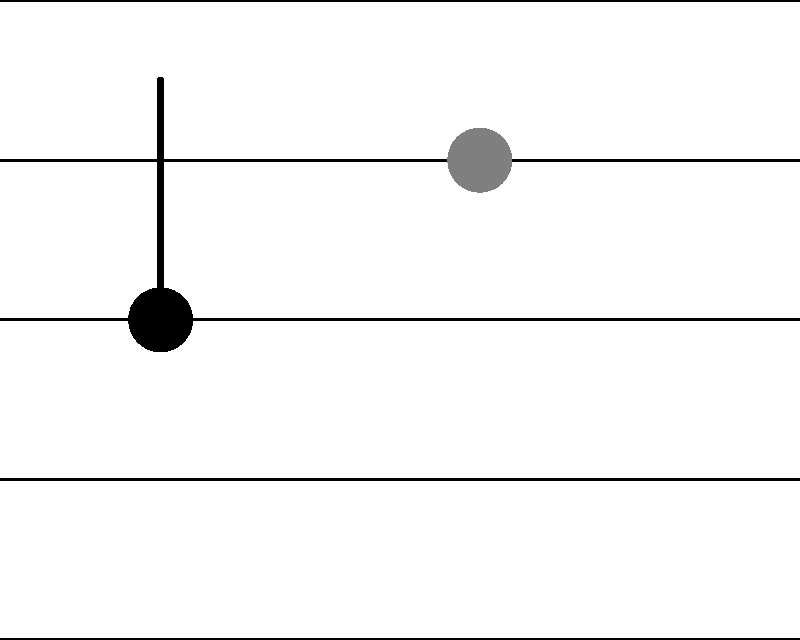In the musical staff above, note A is rotated 135° counterclockwise around point O to create note B. If the coordinates of point A are (1, 2) and the center of rotation O is at (2, 2), what are the coordinates of point B after the rotation? To find the coordinates of point B after rotation, we can use the rotation formula:

1) The general formula for rotating a point $(x, y)$ around the origin by an angle $\theta$ counterclockwise is:
   $x' = x \cos \theta - y \sin \theta$
   $y' = x \sin \theta + y \cos \theta$

2) However, we're rotating around (2, 2), not the origin. So first, we need to translate the point A to the origin:
   $(1, 2) \rightarrow (-1, 0)$

3) Now we apply the rotation formula with $\theta = 135°$:
   $\cos 135° = -\frac{\sqrt{2}}{2}$
   $\sin 135° = \frac{\sqrt{2}}{2}$

   $x' = -1 \cdot (-\frac{\sqrt{2}}{2}) - 0 \cdot \frac{\sqrt{2}}{2} = \frac{\sqrt{2}}{2}$
   $y' = -1 \cdot \frac{\sqrt{2}}{2} + 0 \cdot (-\frac{\sqrt{2}}{2}) = -\frac{\sqrt{2}}{2}$

4) Now we translate back, adding (2, 2):
   $x = \frac{\sqrt{2}}{2} + 2 = 2 + \frac{\sqrt{2}}{2}$
   $y = -\frac{\sqrt{2}}{2} + 2 = 2 - \frac{\sqrt{2}}{2}$

5) Simplifying:
   $x = 2 + \frac{\sqrt{2}}{2} \approx 3$
   $y = 2 - \frac{\sqrt{2}}{2} \approx 3$

Therefore, the coordinates of point B are approximately (3, 3).
Answer: (3, 3) 